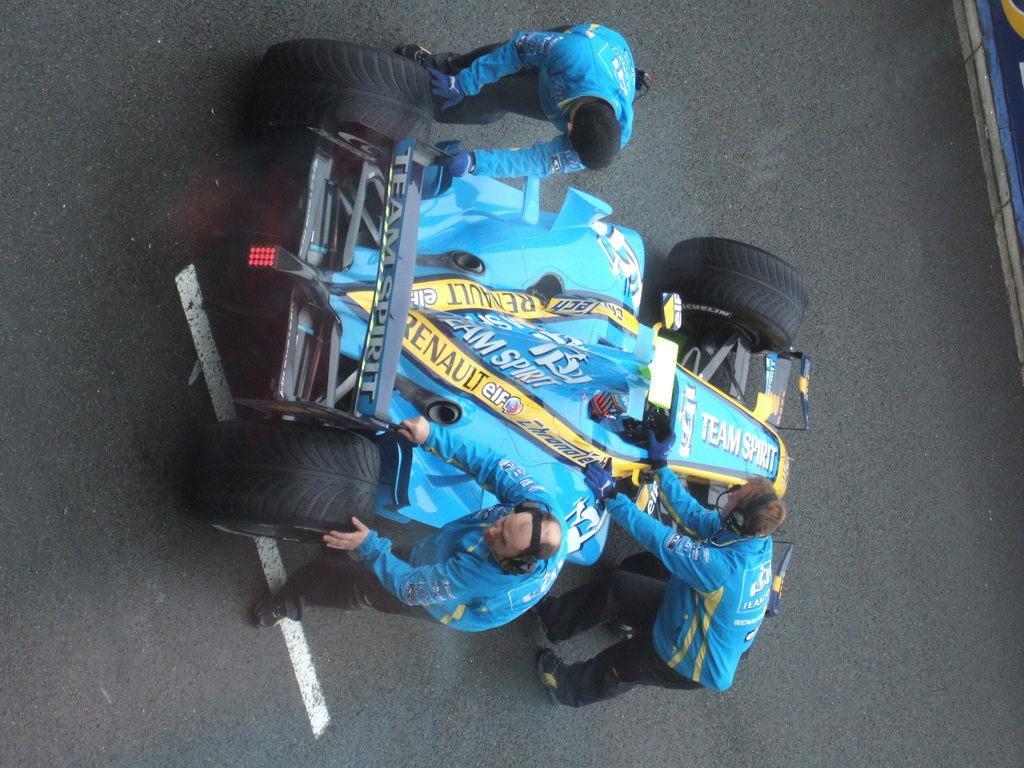Can you describe this image briefly? There is a formula one race car. There are service men who are fixing it with a blue uniform and there are three people who are servicing it. The car is on the road. 